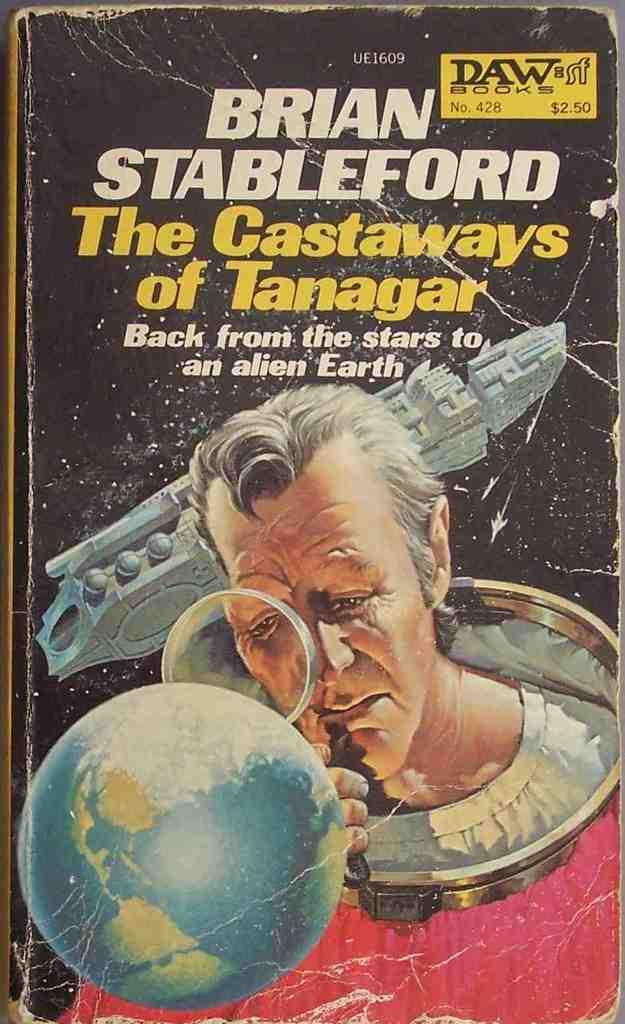<image>
Create a compact narrative representing the image presented. A paperback science fiction book by Brian Stableford. 